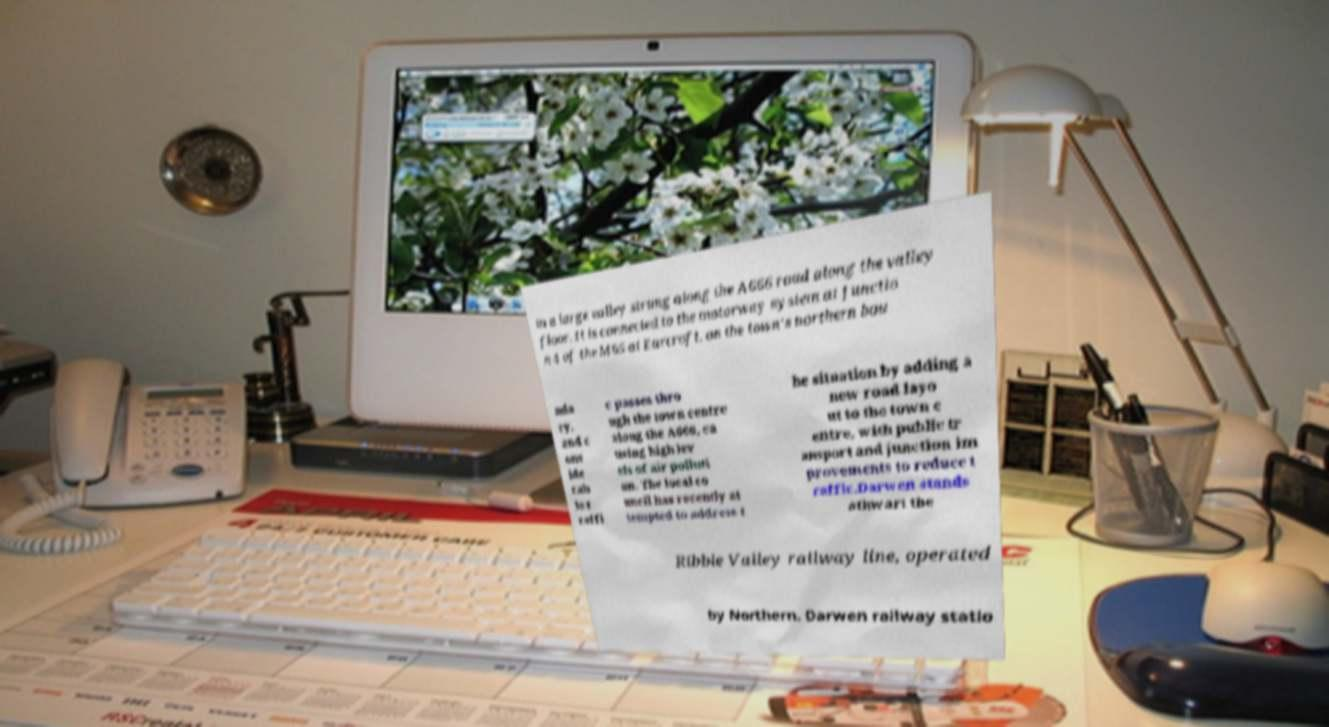For documentation purposes, I need the text within this image transcribed. Could you provide that? in a large valley strung along the A666 road along the valley floor. It is connected to the motorway system at Junctio n 4 of the M65 at Earcroft, on the town's northern bou nda ry, and c ons ide rab le t raffi c passes thro ugh the town centre along the A666, ca using high lev els of air polluti on. The local co uncil has recently at tempted to address t he situation by adding a new road layo ut to the town c entre, with public tr ansport and junction im provements to reduce t raffic.Darwen stands athwart the Ribble Valley railway line, operated by Northern. Darwen railway statio 